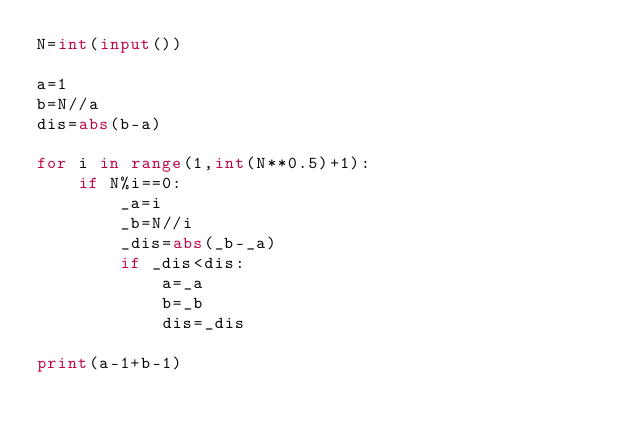<code> <loc_0><loc_0><loc_500><loc_500><_Python_>N=int(input())

a=1
b=N//a
dis=abs(b-a)

for i in range(1,int(N**0.5)+1):
    if N%i==0:
        _a=i
        _b=N//i
        _dis=abs(_b-_a)
        if _dis<dis:
            a=_a
            b=_b
            dis=_dis

print(a-1+b-1)</code> 